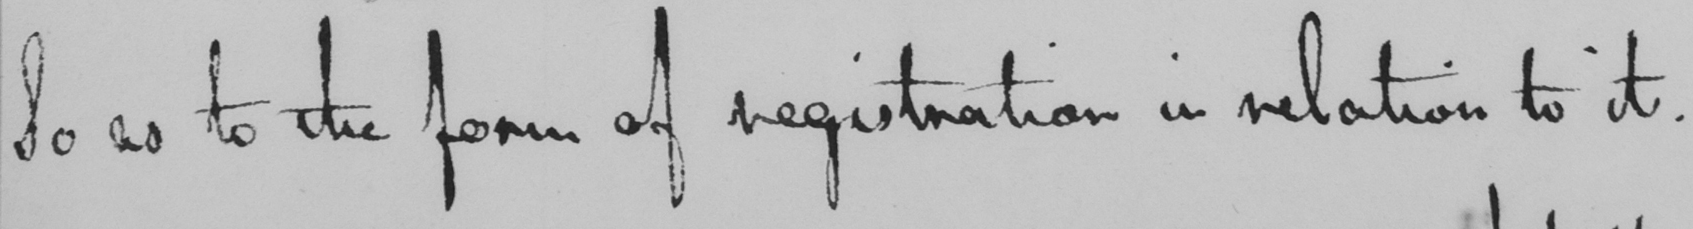Please transcribe the handwritten text in this image. So as to the form of registration in relation to it . 